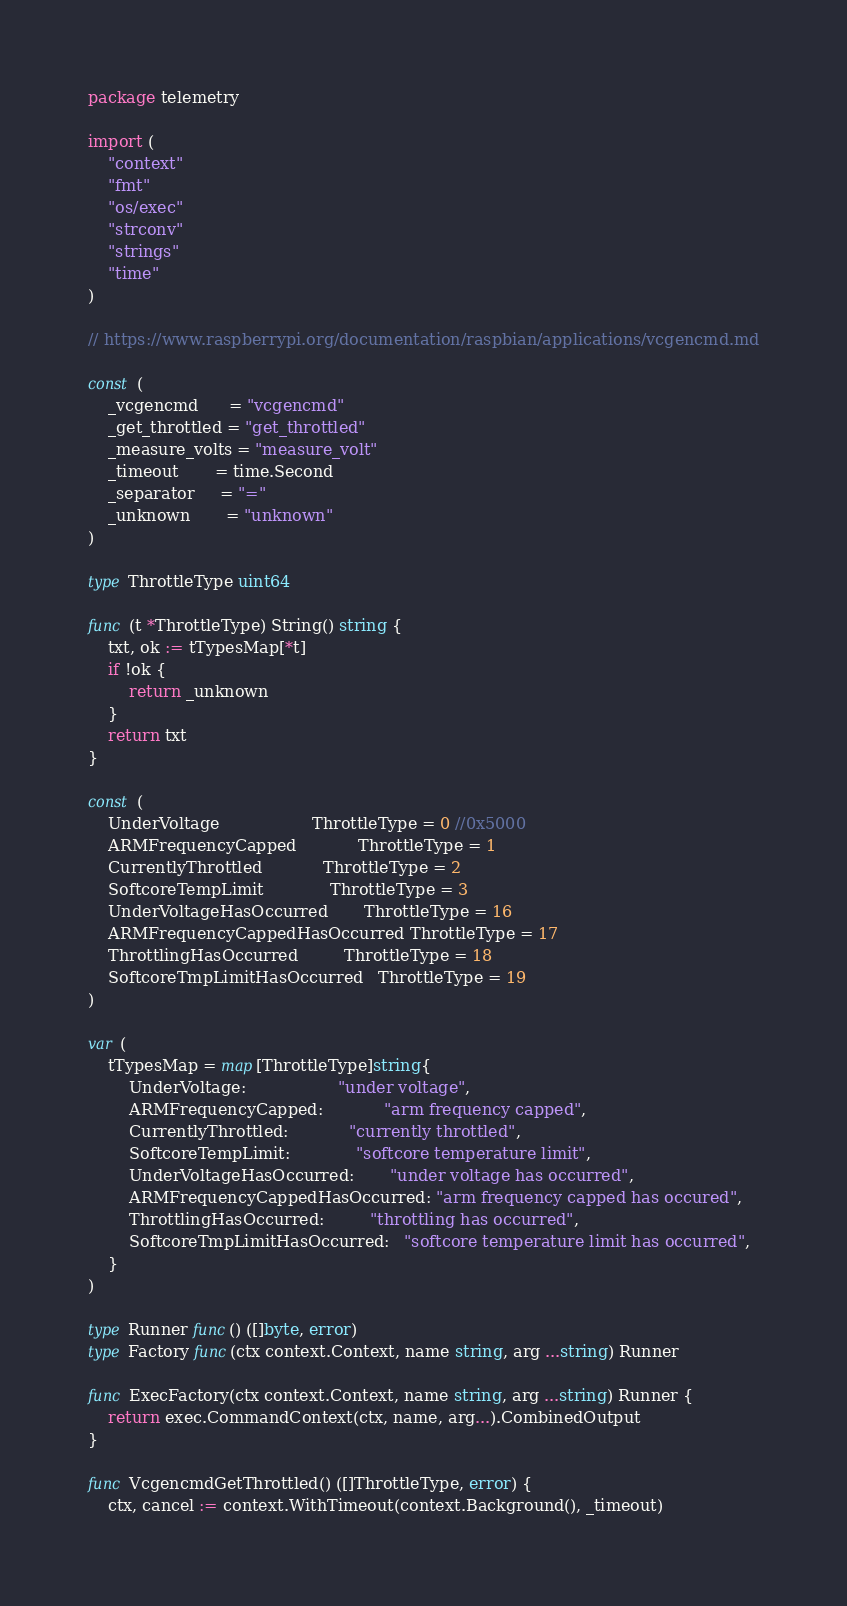Convert code to text. <code><loc_0><loc_0><loc_500><loc_500><_Go_>package telemetry

import (
	"context"
	"fmt"
	"os/exec"
	"strconv"
	"strings"
	"time"
)

// https://www.raspberrypi.org/documentation/raspbian/applications/vcgencmd.md

const (
	_vcgencmd      = "vcgencmd"
	_get_throttled = "get_throttled"
	_measure_volts = "measure_volt"
	_timeout       = time.Second
	_separator     = "="
	_unknown       = "unknown"
)

type ThrottleType uint64

func (t *ThrottleType) String() string {
	txt, ok := tTypesMap[*t]
	if !ok {
		return _unknown
	}
	return txt
}

const (
	UnderVoltage                  ThrottleType = 0 //0x5000
	ARMFrequencyCapped            ThrottleType = 1
	CurrentlyThrottled            ThrottleType = 2
	SoftcoreTempLimit             ThrottleType = 3
	UnderVoltageHasOccurred       ThrottleType = 16
	ARMFrequencyCappedHasOccurred ThrottleType = 17
	ThrottlingHasOccurred         ThrottleType = 18
	SoftcoreTmpLimitHasOccurred   ThrottleType = 19
)

var (
	tTypesMap = map[ThrottleType]string{
		UnderVoltage:                  "under voltage",
		ARMFrequencyCapped:            "arm frequency capped",
		CurrentlyThrottled:            "currently throttled",
		SoftcoreTempLimit:             "softcore temperature limit",
		UnderVoltageHasOccurred:       "under voltage has occurred",
		ARMFrequencyCappedHasOccurred: "arm frequency capped has occured",
		ThrottlingHasOccurred:         "throttling has occurred",
		SoftcoreTmpLimitHasOccurred:   "softcore temperature limit has occurred",
	}
)

type Runner func() ([]byte, error)
type Factory func(ctx context.Context, name string, arg ...string) Runner

func ExecFactory(ctx context.Context, name string, arg ...string) Runner {
	return exec.CommandContext(ctx, name, arg...).CombinedOutput
}

func VcgencmdGetThrottled() ([]ThrottleType, error) {
	ctx, cancel := context.WithTimeout(context.Background(), _timeout)</code> 